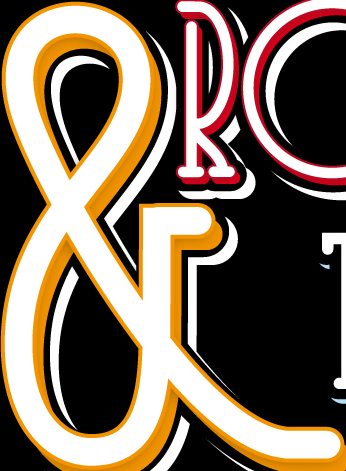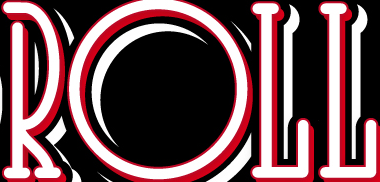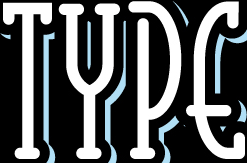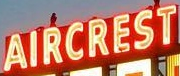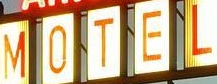Transcribe the words shown in these images in order, separated by a semicolon. &; ROLL; TYPE; AIRCREST; MOTEL 